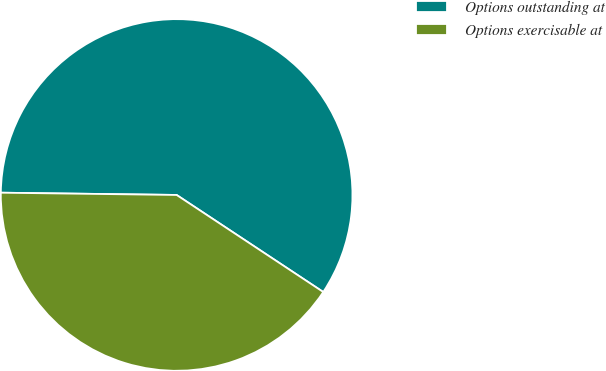<chart> <loc_0><loc_0><loc_500><loc_500><pie_chart><fcel>Options outstanding at<fcel>Options exercisable at<nl><fcel>59.1%<fcel>40.9%<nl></chart> 